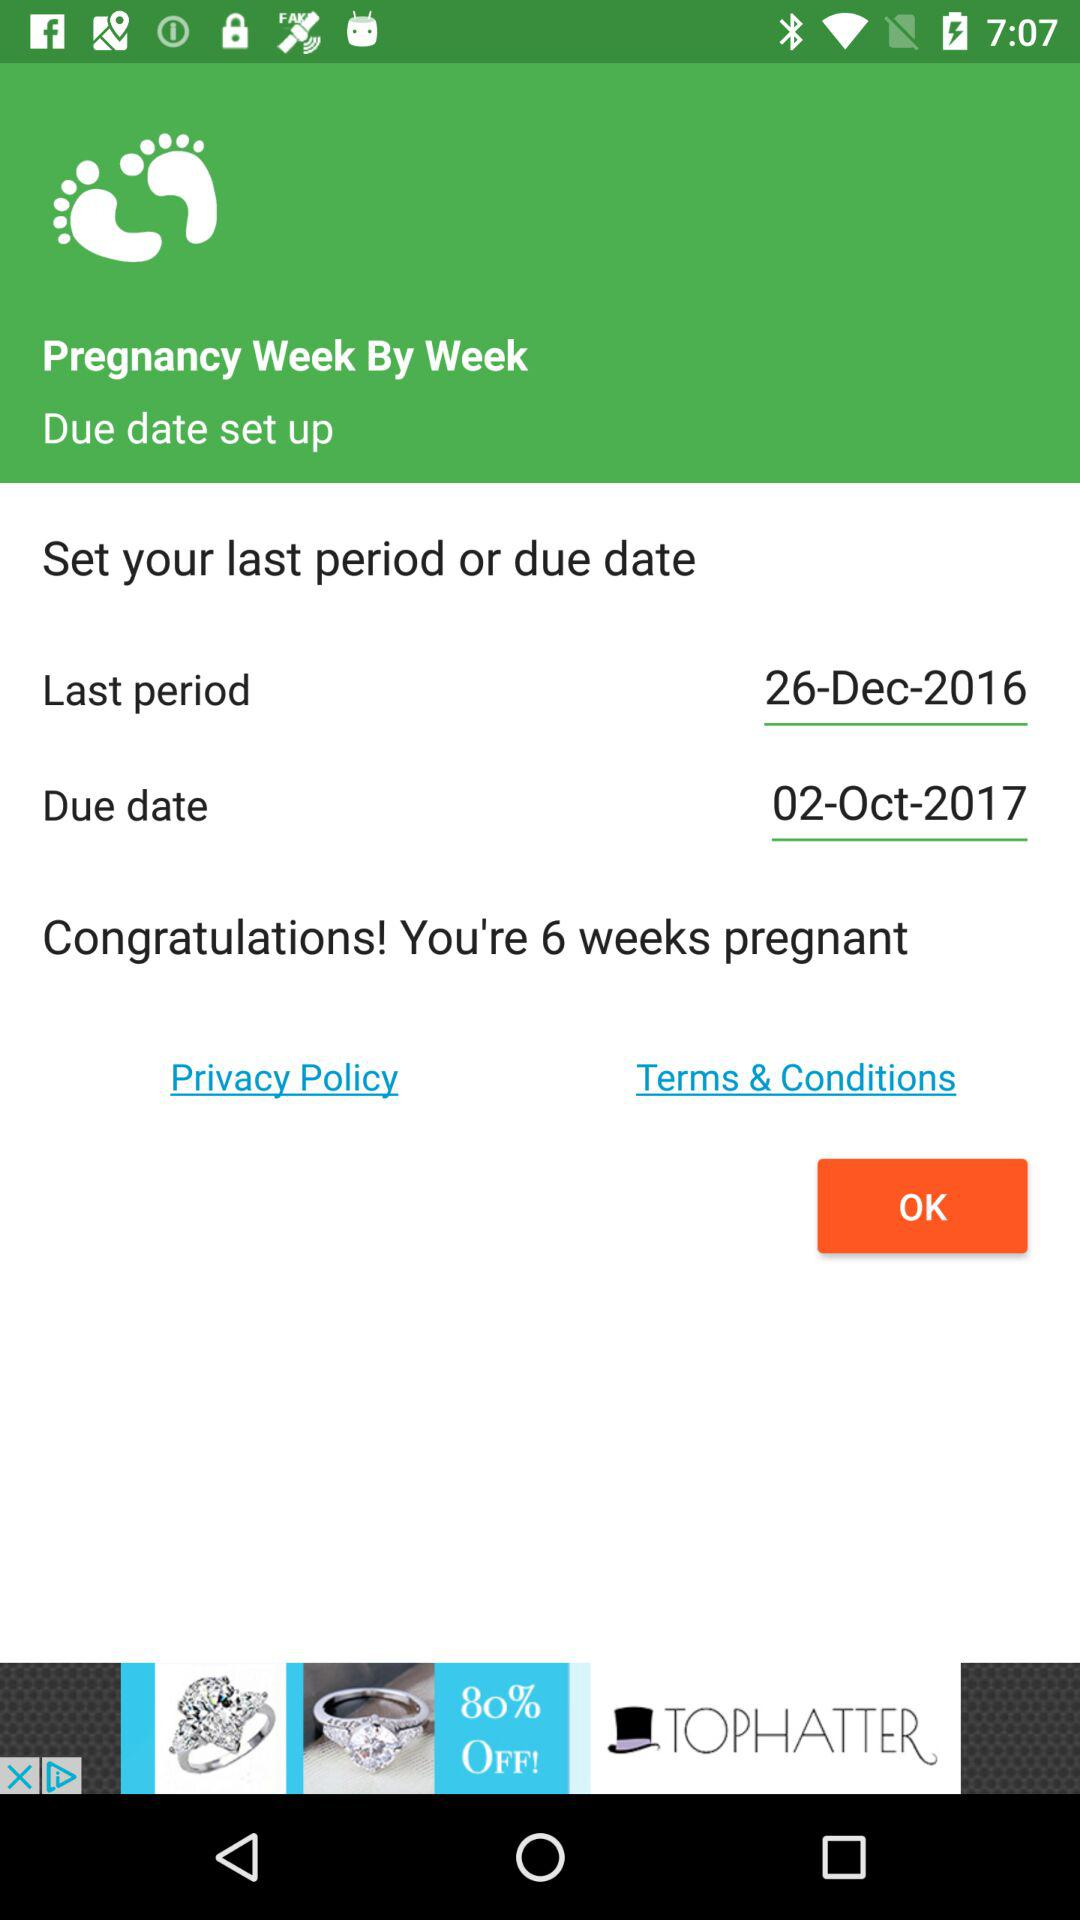What is the due date? The due date is October 2, 2017. 